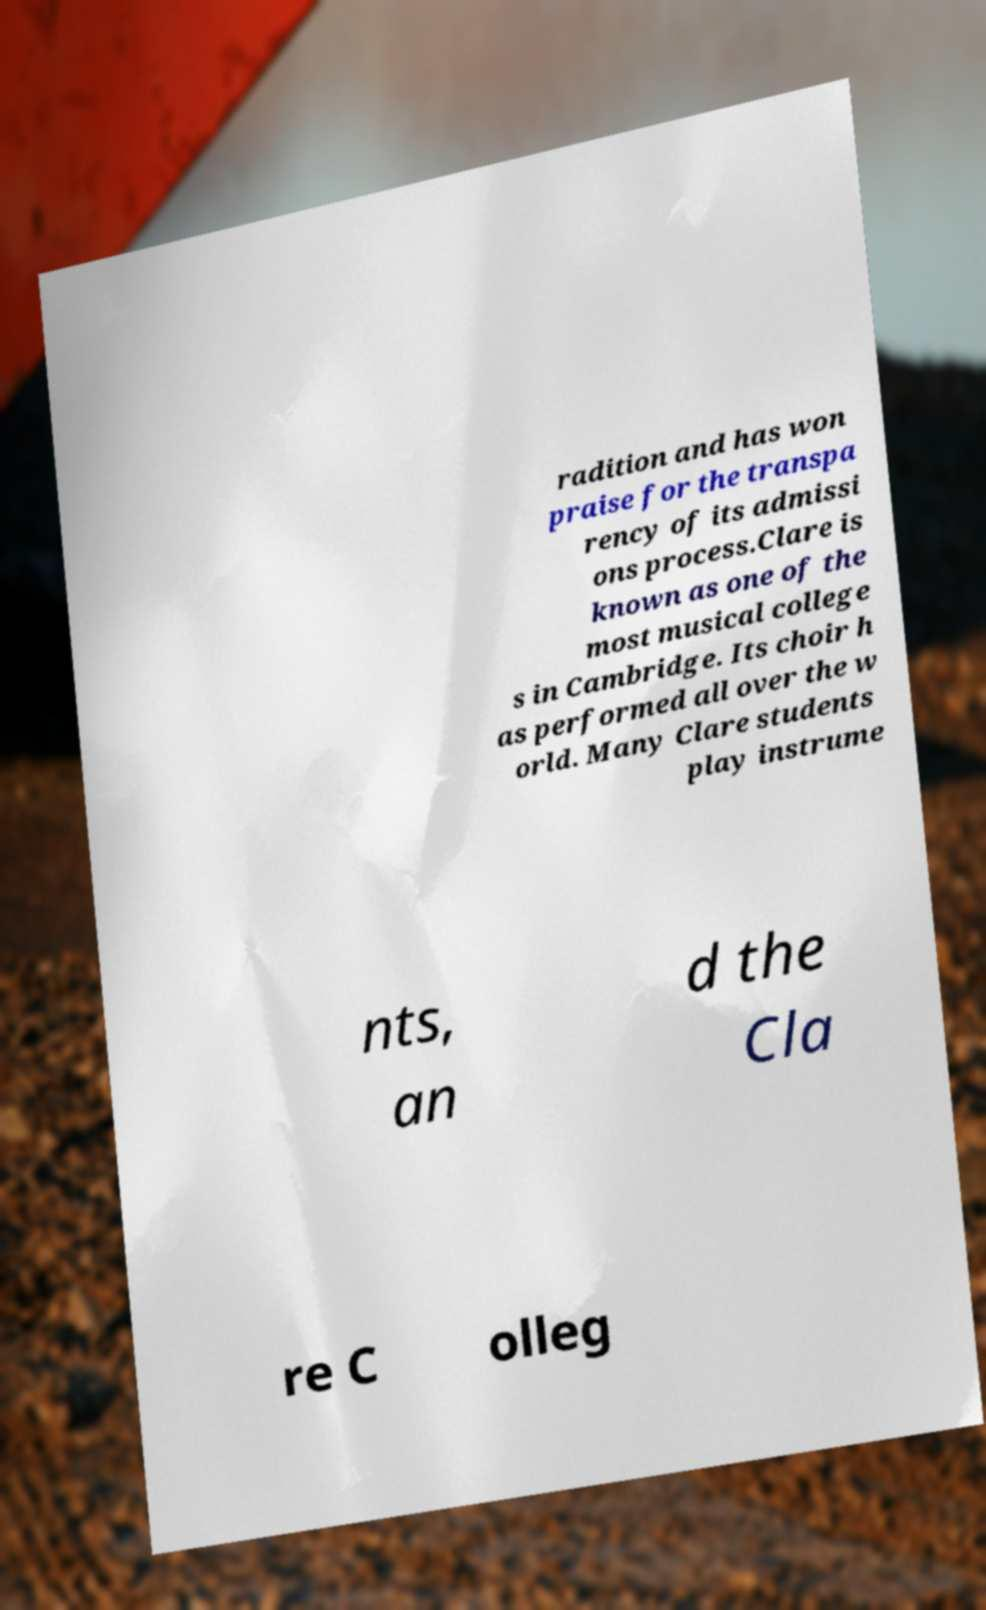I need the written content from this picture converted into text. Can you do that? radition and has won praise for the transpa rency of its admissi ons process.Clare is known as one of the most musical college s in Cambridge. Its choir h as performed all over the w orld. Many Clare students play instrume nts, an d the Cla re C olleg 